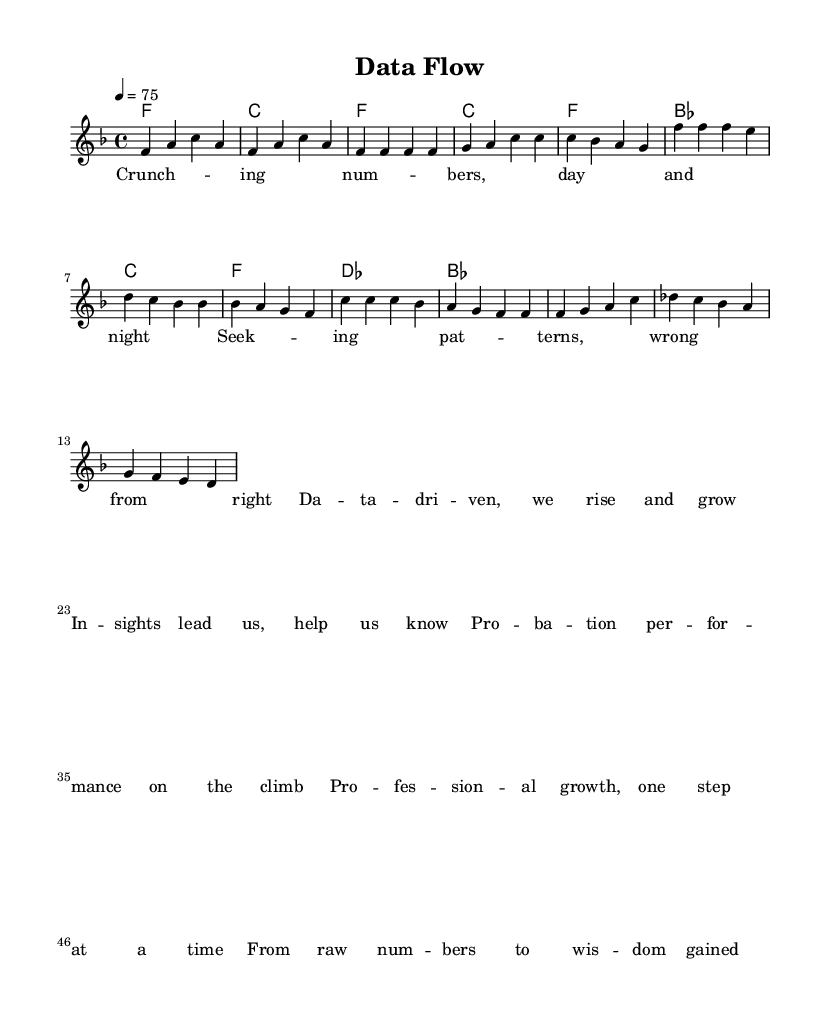What is the key signature of this music? The key signature is F major, which has one flat (B flat). This can be identified by looking at the left side of the staff where the sharps or flats are indicated. In this case, the presence of a flat suggests F major.
Answer: F major What is the time signature of this music? The time signature is 4/4, shown at the beginning of the staff. This means there are four beats per measure, and the quarter note receives one beat. This structure is very common in rhythm and blues music.
Answer: 4/4 What is the tempo marking for this piece? The tempo marking is 75, which is indicated by the marking "4 = 75." This shows the number of beats per minute, providing a measure of the song's pace.
Answer: 75 How many measures are there in the chorus? There are four measures in the chorus, which can be counted by looking at the section indicated by the lyrics set to music under the chorus marker and counting the vertical lines that separate the measures.
Answer: 4 Which type of chord is used in the bridge section? The chords used in the bridge section include des and bes. This can be identified by reviewing the chord names and correlating them with the melody played in those measures. These chords introduce a shift that is characteristic of the bridge in rhythm and blues.
Answer: des, bes What do the lyrics in the verse emphasize? The lyrics in the verse emphasize analysis and decision-making, highlighted by phrases like "Crunching numbers" and "Seeking patterns." This content directly relates to the themes of data-driven decision-making and professional growth embedded in the song.
Answer: Analysis How does the bridge section relate to the overall theme? The bridge section, "From raw numbers to wisdom gained," reinforces the theme of transitioning from basic data analysis to deeper insights, representing a culmination of the song's focus on professional growth and improvement. It's critical for understanding the entire narrative of the song.
Answer: Transition 